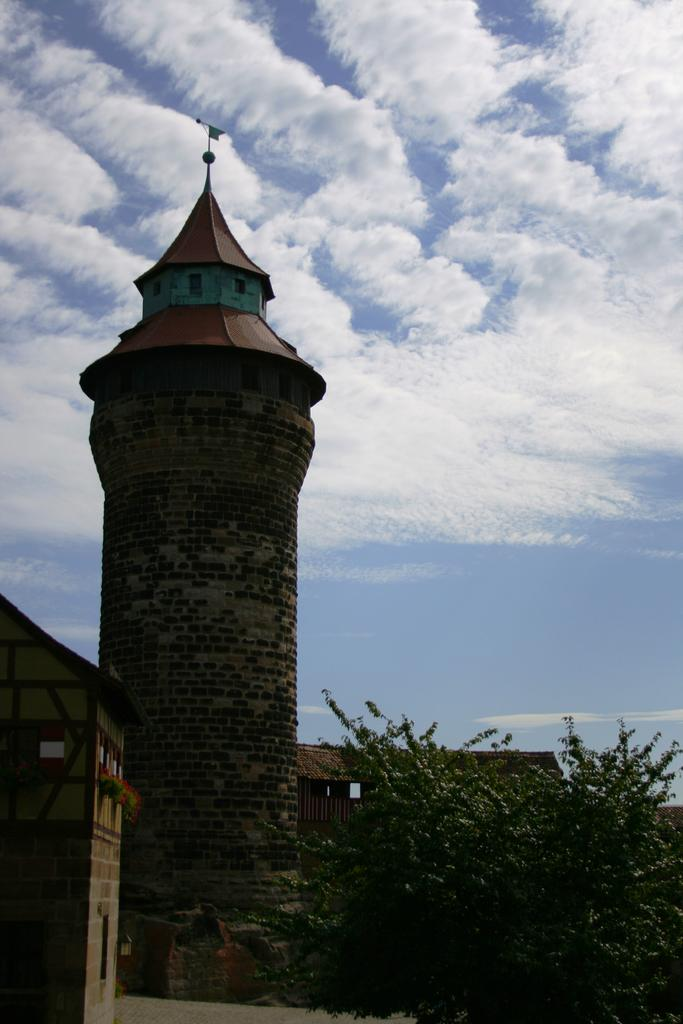What is located at the front of the image? There is a tree in the front of the image. What structure is on the left side of the image? There is a building on the left side of the image. What can be seen in the middle of the image? There is a tower in the middle of the image. What is visible at the top of the image? The sky is visible at the top of the image. How many hands are holding the tree in the image? There are no hands holding the tree in the image; it is a stationary object. What type of lock is securing the tower in the image? There is no lock present on the tower in the image. 